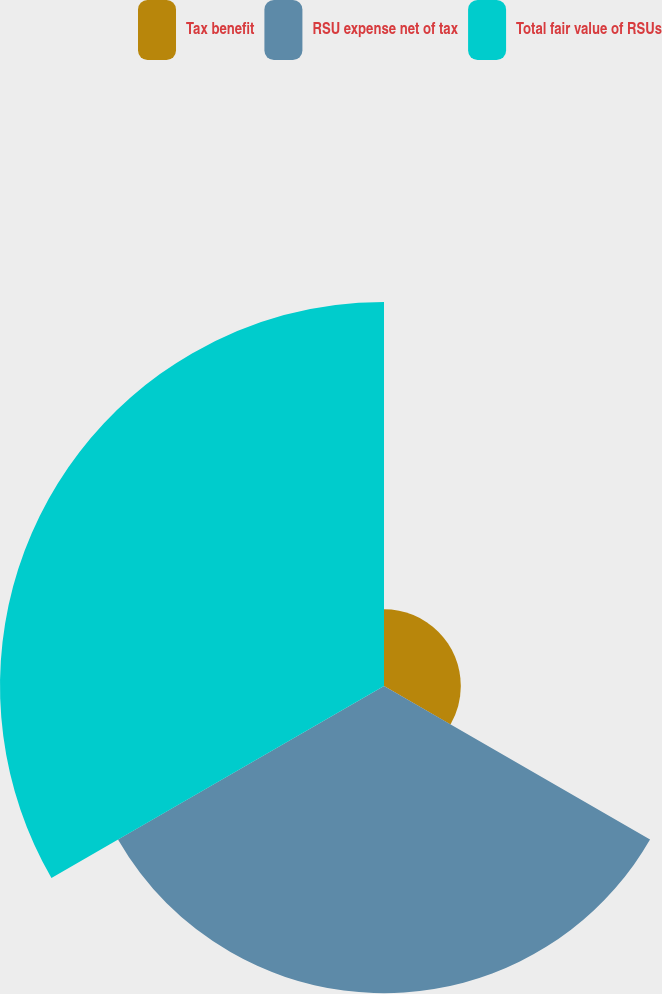<chart> <loc_0><loc_0><loc_500><loc_500><pie_chart><fcel>Tax benefit<fcel>RSU expense net of tax<fcel>Total fair value of RSUs<nl><fcel>10.0%<fcel>40.0%<fcel>50.0%<nl></chart> 